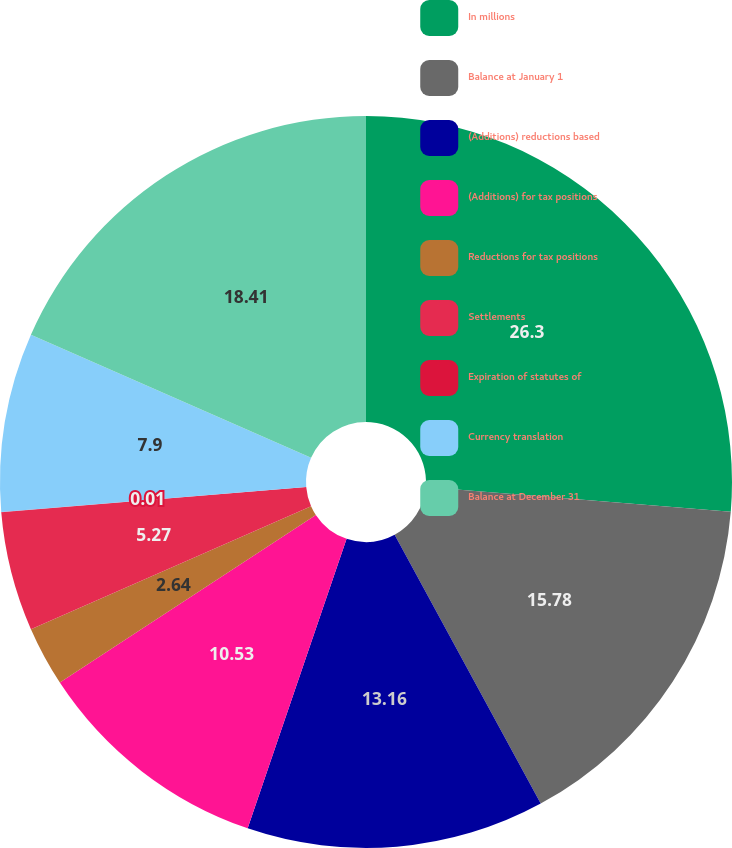<chart> <loc_0><loc_0><loc_500><loc_500><pie_chart><fcel>In millions<fcel>Balance at January 1<fcel>(Additions) reductions based<fcel>(Additions) for tax positions<fcel>Reductions for tax positions<fcel>Settlements<fcel>Expiration of statutes of<fcel>Currency translation<fcel>Balance at December 31<nl><fcel>26.3%<fcel>15.78%<fcel>13.16%<fcel>10.53%<fcel>2.64%<fcel>5.27%<fcel>0.01%<fcel>7.9%<fcel>18.41%<nl></chart> 